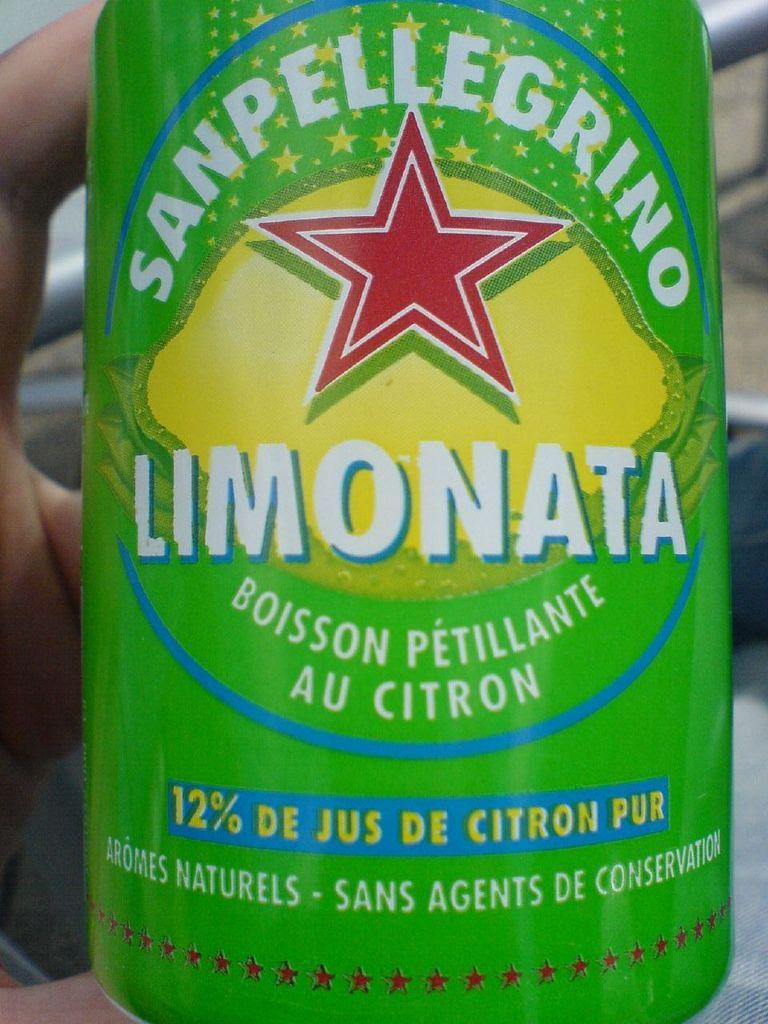<image>
Present a compact description of the photo's key features. The bright green tin of juice is made by Sanpellegrino. 